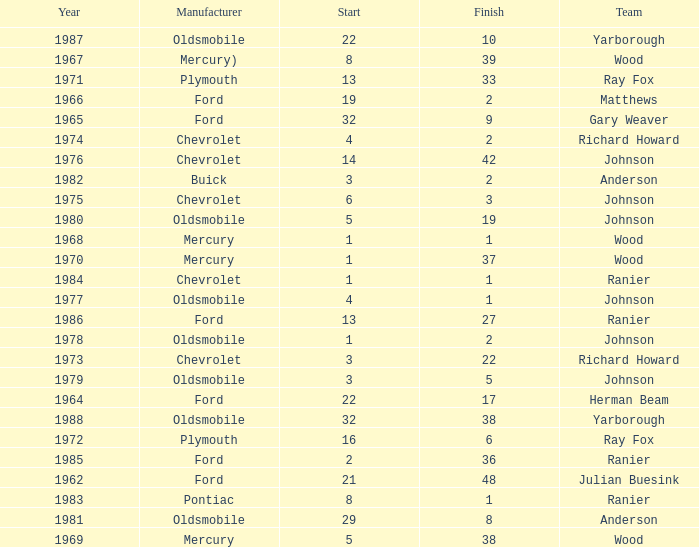Who was the maufacturer of the vehicle during the race where Cale Yarborough started at 19 and finished earlier than 42? Ford. 